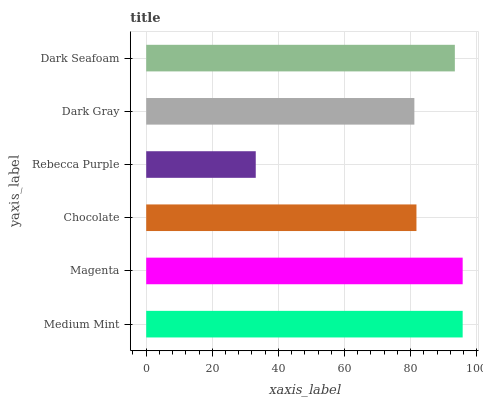Is Rebecca Purple the minimum?
Answer yes or no. Yes. Is Magenta the maximum?
Answer yes or no. Yes. Is Chocolate the minimum?
Answer yes or no. No. Is Chocolate the maximum?
Answer yes or no. No. Is Magenta greater than Chocolate?
Answer yes or no. Yes. Is Chocolate less than Magenta?
Answer yes or no. Yes. Is Chocolate greater than Magenta?
Answer yes or no. No. Is Magenta less than Chocolate?
Answer yes or no. No. Is Dark Seafoam the high median?
Answer yes or no. Yes. Is Chocolate the low median?
Answer yes or no. Yes. Is Rebecca Purple the high median?
Answer yes or no. No. Is Dark Gray the low median?
Answer yes or no. No. 